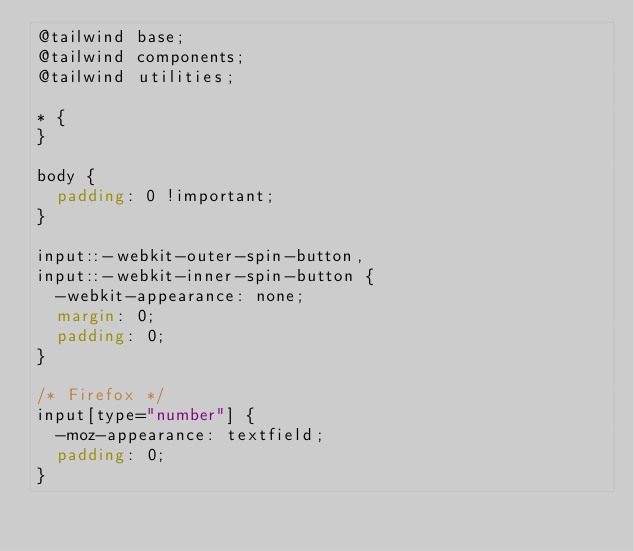Convert code to text. <code><loc_0><loc_0><loc_500><loc_500><_CSS_>@tailwind base;
@tailwind components;
@tailwind utilities;

* {
}

body {
  padding: 0 !important;
}

input::-webkit-outer-spin-button,
input::-webkit-inner-spin-button {
  -webkit-appearance: none;
  margin: 0;
  padding: 0;
}

/* Firefox */
input[type="number"] {
  -moz-appearance: textfield;
  padding: 0;
}</code> 